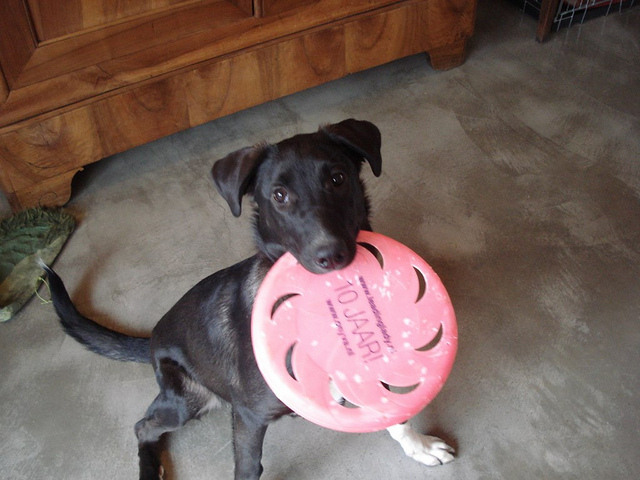Identify the text contained in this image. JAARI 10 JAARI 